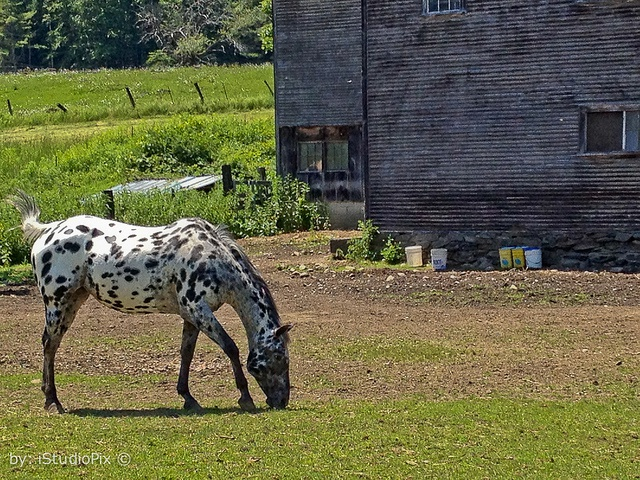Describe the objects in this image and their specific colors. I can see a horse in olive, black, gray, darkgray, and white tones in this image. 